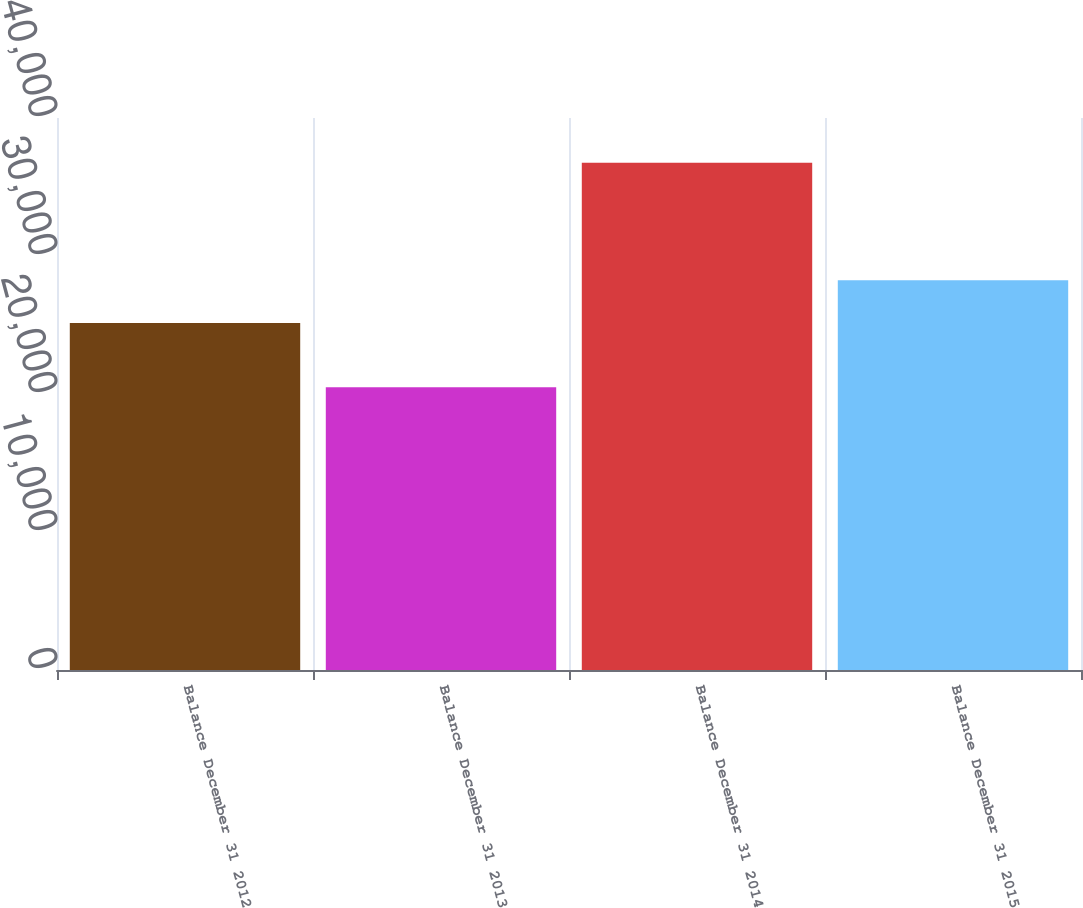Convert chart to OTSL. <chart><loc_0><loc_0><loc_500><loc_500><bar_chart><fcel>Balance December 31 2012<fcel>Balance December 31 2013<fcel>Balance December 31 2014<fcel>Balance December 31 2015<nl><fcel>25151<fcel>20494<fcel>36764<fcel>28240<nl></chart> 